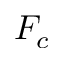<formula> <loc_0><loc_0><loc_500><loc_500>F _ { c }</formula> 